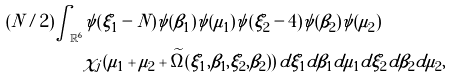Convert formula to latex. <formula><loc_0><loc_0><loc_500><loc_500>( N / 2 ) \int _ { \mathbb { R } ^ { 6 } } & \psi ( \xi _ { 1 } - N ) \psi ( \beta _ { 1 } ) \psi ( \mu _ { 1 } ) \psi ( \xi _ { 2 } - 4 ) \psi ( \beta _ { 2 } ) \psi ( \mu _ { 2 } ) \\ & \chi _ { j } ( \mu _ { 1 } + \mu _ { 2 } + \widetilde { \Omega } ( \xi _ { 1 } , \beta _ { 1 } , \xi _ { 2 } , \beta _ { 2 } ) ) \, d \xi _ { 1 } d \beta _ { 1 } d \mu _ { 1 } d \xi _ { 2 } d \beta _ { 2 } d \mu _ { 2 } ,</formula> 